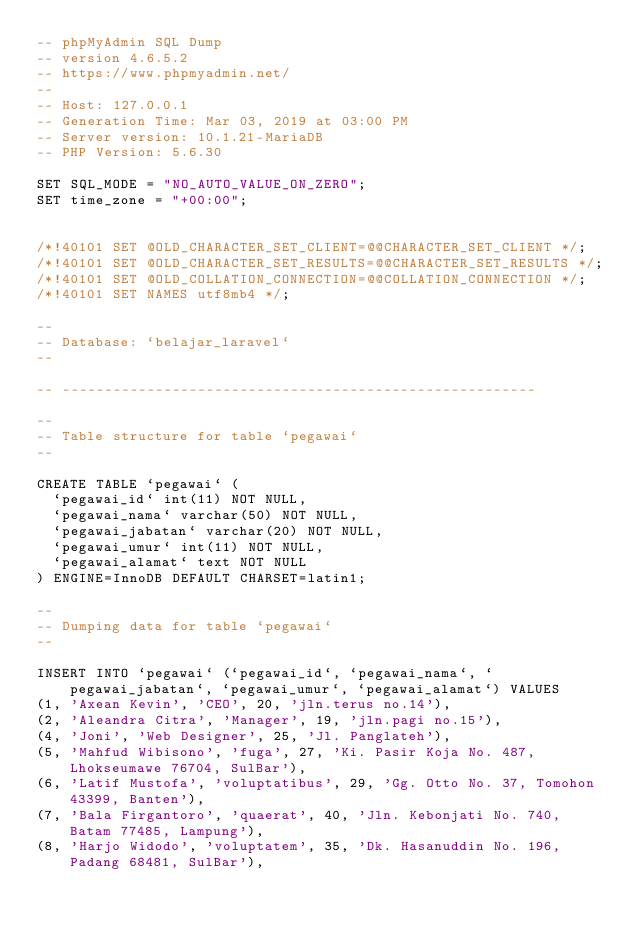<code> <loc_0><loc_0><loc_500><loc_500><_SQL_>-- phpMyAdmin SQL Dump
-- version 4.6.5.2
-- https://www.phpmyadmin.net/
--
-- Host: 127.0.0.1
-- Generation Time: Mar 03, 2019 at 03:00 PM
-- Server version: 10.1.21-MariaDB
-- PHP Version: 5.6.30

SET SQL_MODE = "NO_AUTO_VALUE_ON_ZERO";
SET time_zone = "+00:00";


/*!40101 SET @OLD_CHARACTER_SET_CLIENT=@@CHARACTER_SET_CLIENT */;
/*!40101 SET @OLD_CHARACTER_SET_RESULTS=@@CHARACTER_SET_RESULTS */;
/*!40101 SET @OLD_COLLATION_CONNECTION=@@COLLATION_CONNECTION */;
/*!40101 SET NAMES utf8mb4 */;

--
-- Database: `belajar_laravel`
--

-- --------------------------------------------------------

--
-- Table structure for table `pegawai`
--

CREATE TABLE `pegawai` (
  `pegawai_id` int(11) NOT NULL,
  `pegawai_nama` varchar(50) NOT NULL,
  `pegawai_jabatan` varchar(20) NOT NULL,
  `pegawai_umur` int(11) NOT NULL,
  `pegawai_alamat` text NOT NULL
) ENGINE=InnoDB DEFAULT CHARSET=latin1;

--
-- Dumping data for table `pegawai`
--

INSERT INTO `pegawai` (`pegawai_id`, `pegawai_nama`, `pegawai_jabatan`, `pegawai_umur`, `pegawai_alamat`) VALUES
(1, 'Axean Kevin', 'CEO', 20, 'jln.terus no.14'),
(2, 'Aleandra Citra', 'Manager', 19, 'jln.pagi no.15'),
(4, 'Joni', 'Web Designer', 25, 'Jl. Panglateh'),
(5, 'Mahfud Wibisono', 'fuga', 27, 'Ki. Pasir Koja No. 487, Lhokseumawe 76704, SulBar'),
(6, 'Latif Mustofa', 'voluptatibus', 29, 'Gg. Otto No. 37, Tomohon 43399, Banten'),
(7, 'Bala Firgantoro', 'quaerat', 40, 'Jln. Kebonjati No. 740, Batam 77485, Lampung'),
(8, 'Harjo Widodo', 'voluptatem', 35, 'Dk. Hasanuddin No. 196, Padang 68481, SulBar'),</code> 